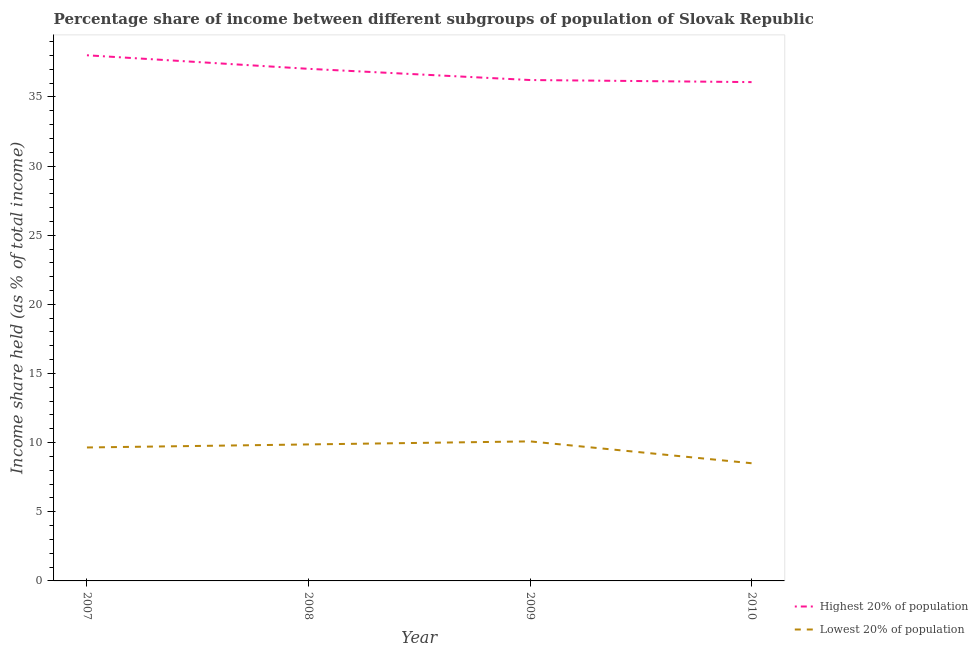What is the income share held by highest 20% of the population in 2007?
Your answer should be compact. 38.01. Across all years, what is the maximum income share held by highest 20% of the population?
Your answer should be compact. 38.01. Across all years, what is the minimum income share held by lowest 20% of the population?
Keep it short and to the point. 8.51. In which year was the income share held by highest 20% of the population maximum?
Offer a terse response. 2007. What is the total income share held by highest 20% of the population in the graph?
Give a very brief answer. 147.33. What is the difference between the income share held by highest 20% of the population in 2008 and that in 2010?
Keep it short and to the point. 0.96. What is the difference between the income share held by lowest 20% of the population in 2009 and the income share held by highest 20% of the population in 2007?
Provide a short and direct response. -27.92. What is the average income share held by highest 20% of the population per year?
Provide a succinct answer. 36.83. In the year 2010, what is the difference between the income share held by lowest 20% of the population and income share held by highest 20% of the population?
Give a very brief answer. -27.56. What is the ratio of the income share held by lowest 20% of the population in 2007 to that in 2008?
Offer a terse response. 0.98. What is the difference between the highest and the second highest income share held by lowest 20% of the population?
Ensure brevity in your answer.  0.22. What is the difference between the highest and the lowest income share held by highest 20% of the population?
Ensure brevity in your answer.  1.94. In how many years, is the income share held by highest 20% of the population greater than the average income share held by highest 20% of the population taken over all years?
Ensure brevity in your answer.  2. Is the sum of the income share held by lowest 20% of the population in 2007 and 2009 greater than the maximum income share held by highest 20% of the population across all years?
Your answer should be compact. No. How many lines are there?
Offer a terse response. 2. Are the values on the major ticks of Y-axis written in scientific E-notation?
Offer a terse response. No. Does the graph contain any zero values?
Your answer should be very brief. No. Where does the legend appear in the graph?
Provide a short and direct response. Bottom right. How are the legend labels stacked?
Provide a succinct answer. Vertical. What is the title of the graph?
Ensure brevity in your answer.  Percentage share of income between different subgroups of population of Slovak Republic. What is the label or title of the Y-axis?
Your response must be concise. Income share held (as % of total income). What is the Income share held (as % of total income) of Highest 20% of population in 2007?
Ensure brevity in your answer.  38.01. What is the Income share held (as % of total income) in Lowest 20% of population in 2007?
Provide a succinct answer. 9.65. What is the Income share held (as % of total income) in Highest 20% of population in 2008?
Give a very brief answer. 37.03. What is the Income share held (as % of total income) in Lowest 20% of population in 2008?
Your response must be concise. 9.87. What is the Income share held (as % of total income) of Highest 20% of population in 2009?
Make the answer very short. 36.22. What is the Income share held (as % of total income) in Lowest 20% of population in 2009?
Your answer should be very brief. 10.09. What is the Income share held (as % of total income) of Highest 20% of population in 2010?
Make the answer very short. 36.07. What is the Income share held (as % of total income) of Lowest 20% of population in 2010?
Offer a terse response. 8.51. Across all years, what is the maximum Income share held (as % of total income) in Highest 20% of population?
Offer a terse response. 38.01. Across all years, what is the maximum Income share held (as % of total income) of Lowest 20% of population?
Ensure brevity in your answer.  10.09. Across all years, what is the minimum Income share held (as % of total income) of Highest 20% of population?
Offer a very short reply. 36.07. Across all years, what is the minimum Income share held (as % of total income) in Lowest 20% of population?
Ensure brevity in your answer.  8.51. What is the total Income share held (as % of total income) of Highest 20% of population in the graph?
Provide a succinct answer. 147.33. What is the total Income share held (as % of total income) of Lowest 20% of population in the graph?
Offer a terse response. 38.12. What is the difference between the Income share held (as % of total income) of Highest 20% of population in 2007 and that in 2008?
Make the answer very short. 0.98. What is the difference between the Income share held (as % of total income) of Lowest 20% of population in 2007 and that in 2008?
Ensure brevity in your answer.  -0.22. What is the difference between the Income share held (as % of total income) in Highest 20% of population in 2007 and that in 2009?
Your answer should be compact. 1.79. What is the difference between the Income share held (as % of total income) of Lowest 20% of population in 2007 and that in 2009?
Ensure brevity in your answer.  -0.44. What is the difference between the Income share held (as % of total income) of Highest 20% of population in 2007 and that in 2010?
Your response must be concise. 1.94. What is the difference between the Income share held (as % of total income) in Lowest 20% of population in 2007 and that in 2010?
Give a very brief answer. 1.14. What is the difference between the Income share held (as % of total income) of Highest 20% of population in 2008 and that in 2009?
Offer a very short reply. 0.81. What is the difference between the Income share held (as % of total income) of Lowest 20% of population in 2008 and that in 2009?
Offer a very short reply. -0.22. What is the difference between the Income share held (as % of total income) of Highest 20% of population in 2008 and that in 2010?
Provide a succinct answer. 0.96. What is the difference between the Income share held (as % of total income) of Lowest 20% of population in 2008 and that in 2010?
Provide a short and direct response. 1.36. What is the difference between the Income share held (as % of total income) of Highest 20% of population in 2009 and that in 2010?
Provide a short and direct response. 0.15. What is the difference between the Income share held (as % of total income) of Lowest 20% of population in 2009 and that in 2010?
Make the answer very short. 1.58. What is the difference between the Income share held (as % of total income) of Highest 20% of population in 2007 and the Income share held (as % of total income) of Lowest 20% of population in 2008?
Offer a very short reply. 28.14. What is the difference between the Income share held (as % of total income) of Highest 20% of population in 2007 and the Income share held (as % of total income) of Lowest 20% of population in 2009?
Give a very brief answer. 27.92. What is the difference between the Income share held (as % of total income) of Highest 20% of population in 2007 and the Income share held (as % of total income) of Lowest 20% of population in 2010?
Ensure brevity in your answer.  29.5. What is the difference between the Income share held (as % of total income) of Highest 20% of population in 2008 and the Income share held (as % of total income) of Lowest 20% of population in 2009?
Ensure brevity in your answer.  26.94. What is the difference between the Income share held (as % of total income) of Highest 20% of population in 2008 and the Income share held (as % of total income) of Lowest 20% of population in 2010?
Your answer should be very brief. 28.52. What is the difference between the Income share held (as % of total income) in Highest 20% of population in 2009 and the Income share held (as % of total income) in Lowest 20% of population in 2010?
Offer a terse response. 27.71. What is the average Income share held (as % of total income) of Highest 20% of population per year?
Offer a very short reply. 36.83. What is the average Income share held (as % of total income) in Lowest 20% of population per year?
Make the answer very short. 9.53. In the year 2007, what is the difference between the Income share held (as % of total income) in Highest 20% of population and Income share held (as % of total income) in Lowest 20% of population?
Your answer should be very brief. 28.36. In the year 2008, what is the difference between the Income share held (as % of total income) of Highest 20% of population and Income share held (as % of total income) of Lowest 20% of population?
Your answer should be compact. 27.16. In the year 2009, what is the difference between the Income share held (as % of total income) in Highest 20% of population and Income share held (as % of total income) in Lowest 20% of population?
Offer a very short reply. 26.13. In the year 2010, what is the difference between the Income share held (as % of total income) of Highest 20% of population and Income share held (as % of total income) of Lowest 20% of population?
Keep it short and to the point. 27.56. What is the ratio of the Income share held (as % of total income) in Highest 20% of population in 2007 to that in 2008?
Make the answer very short. 1.03. What is the ratio of the Income share held (as % of total income) of Lowest 20% of population in 2007 to that in 2008?
Ensure brevity in your answer.  0.98. What is the ratio of the Income share held (as % of total income) of Highest 20% of population in 2007 to that in 2009?
Offer a very short reply. 1.05. What is the ratio of the Income share held (as % of total income) of Lowest 20% of population in 2007 to that in 2009?
Your answer should be compact. 0.96. What is the ratio of the Income share held (as % of total income) in Highest 20% of population in 2007 to that in 2010?
Your answer should be compact. 1.05. What is the ratio of the Income share held (as % of total income) in Lowest 20% of population in 2007 to that in 2010?
Ensure brevity in your answer.  1.13. What is the ratio of the Income share held (as % of total income) in Highest 20% of population in 2008 to that in 2009?
Make the answer very short. 1.02. What is the ratio of the Income share held (as % of total income) of Lowest 20% of population in 2008 to that in 2009?
Offer a terse response. 0.98. What is the ratio of the Income share held (as % of total income) of Highest 20% of population in 2008 to that in 2010?
Your answer should be compact. 1.03. What is the ratio of the Income share held (as % of total income) of Lowest 20% of population in 2008 to that in 2010?
Provide a short and direct response. 1.16. What is the ratio of the Income share held (as % of total income) in Lowest 20% of population in 2009 to that in 2010?
Offer a very short reply. 1.19. What is the difference between the highest and the second highest Income share held (as % of total income) in Lowest 20% of population?
Ensure brevity in your answer.  0.22. What is the difference between the highest and the lowest Income share held (as % of total income) in Highest 20% of population?
Offer a terse response. 1.94. What is the difference between the highest and the lowest Income share held (as % of total income) in Lowest 20% of population?
Give a very brief answer. 1.58. 